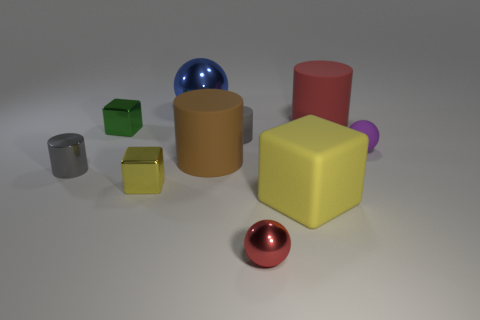How many objects are small gray things that are in front of the small rubber cylinder or objects that are behind the tiny matte cylinder?
Your response must be concise. 4. How many large cylinders are left of the ball in front of the purple sphere?
Offer a terse response. 1. There is a gray object that is on the left side of the green thing; is it the same shape as the gray object to the right of the shiny cylinder?
Your answer should be very brief. Yes. What shape is the tiny rubber thing that is the same color as the small shiny cylinder?
Offer a terse response. Cylinder. Is there a brown thing made of the same material as the small red object?
Provide a short and direct response. No. What number of metal objects are either small gray cylinders or blocks?
Offer a very short reply. 3. There is a red object that is to the left of the matte cylinder that is right of the small matte cylinder; what shape is it?
Ensure brevity in your answer.  Sphere. Is the number of metallic things that are behind the small purple object less than the number of big purple rubber things?
Your answer should be compact. No. What is the shape of the large brown matte object?
Your response must be concise. Cylinder. How big is the yellow object that is left of the large yellow thing?
Your answer should be very brief. Small. 